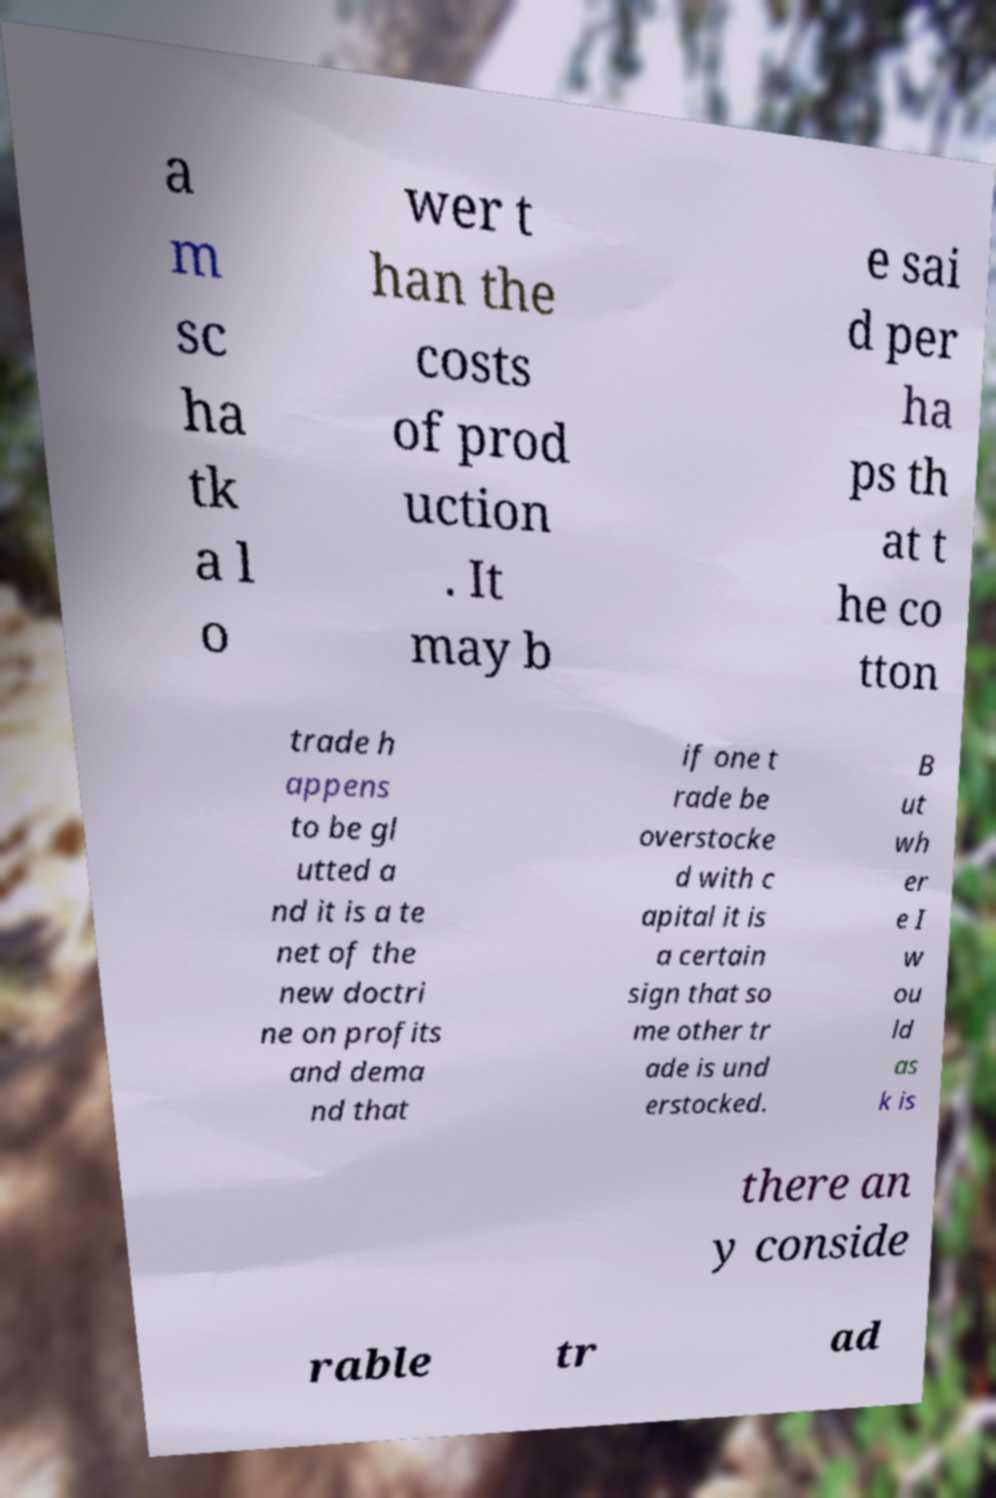Please identify and transcribe the text found in this image. a m sc ha tk a l o wer t han the costs of prod uction . It may b e sai d per ha ps th at t he co tton trade h appens to be gl utted a nd it is a te net of the new doctri ne on profits and dema nd that if one t rade be overstocke d with c apital it is a certain sign that so me other tr ade is und erstocked. B ut wh er e I w ou ld as k is there an y conside rable tr ad 